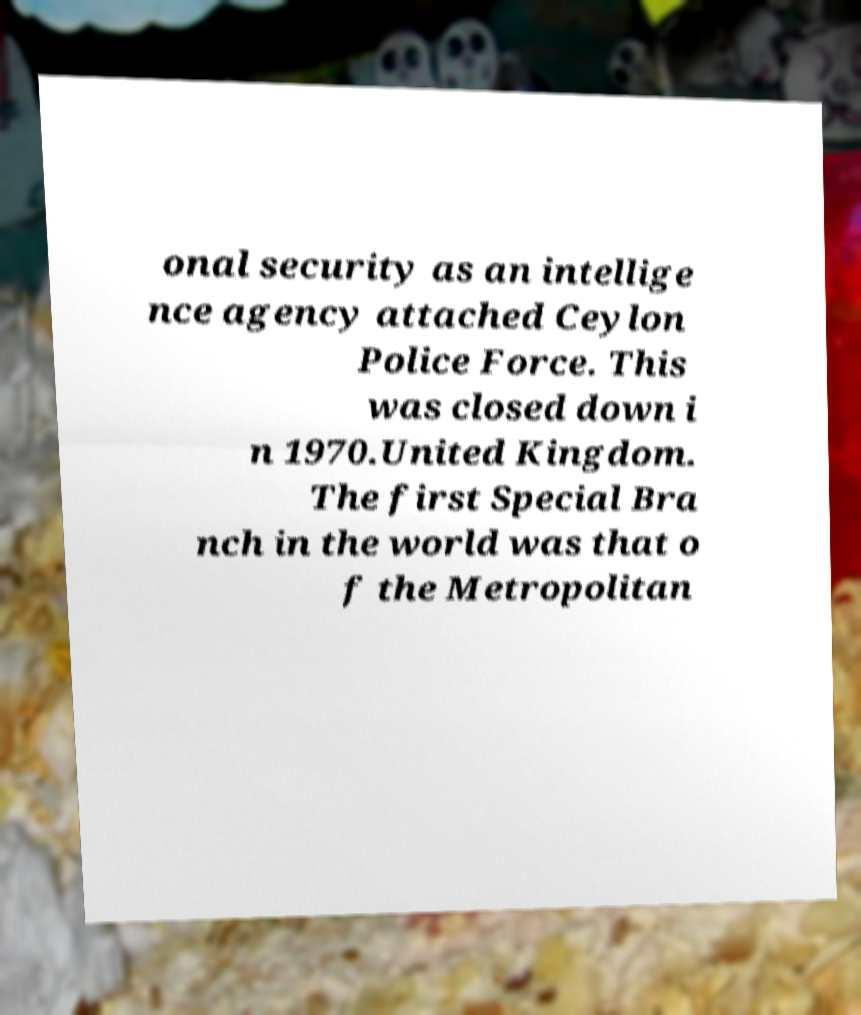Please identify and transcribe the text found in this image. onal security as an intellige nce agency attached Ceylon Police Force. This was closed down i n 1970.United Kingdom. The first Special Bra nch in the world was that o f the Metropolitan 